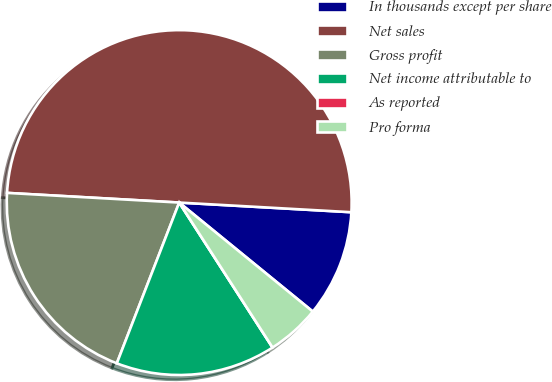Convert chart to OTSL. <chart><loc_0><loc_0><loc_500><loc_500><pie_chart><fcel>In thousands except per share<fcel>Net sales<fcel>Gross profit<fcel>Net income attributable to<fcel>As reported<fcel>Pro forma<nl><fcel>10.0%<fcel>50.0%<fcel>20.0%<fcel>15.0%<fcel>0.0%<fcel>5.0%<nl></chart> 